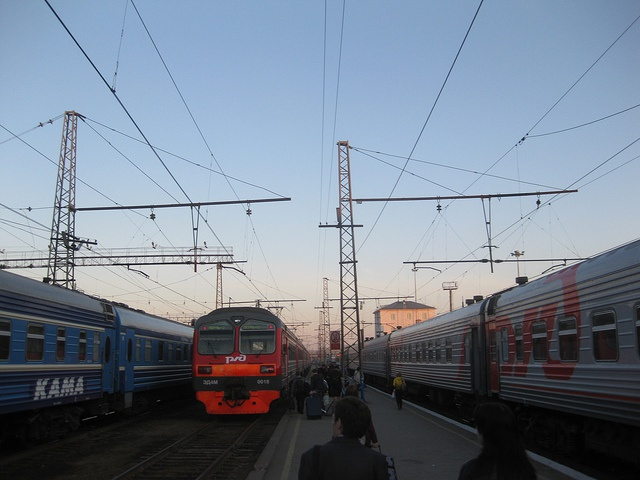Describe the objects in this image and their specific colors. I can see train in gray, black, and maroon tones, train in gray, black, navy, and blue tones, train in gray, black, and maroon tones, people in gray and black tones, and people in black and gray tones in this image. 